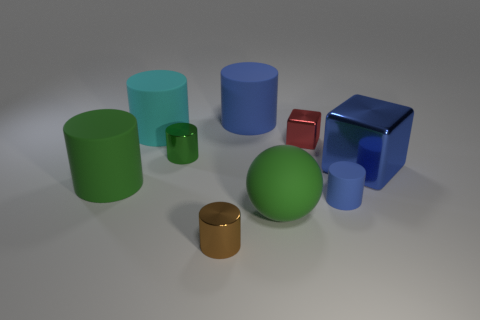Subtract all matte cylinders. How many cylinders are left? 2 Subtract all cyan cylinders. How many cylinders are left? 5 Subtract all green blocks. How many blue cylinders are left? 2 Subtract 3 cylinders. How many cylinders are left? 3 Add 1 big red matte cylinders. How many objects exist? 10 Subtract all cyan cylinders. Subtract all brown cubes. How many cylinders are left? 5 Subtract all cylinders. How many objects are left? 3 Subtract 1 blue cubes. How many objects are left? 8 Subtract all large blue rubber balls. Subtract all small metal blocks. How many objects are left? 8 Add 3 big matte things. How many big matte things are left? 7 